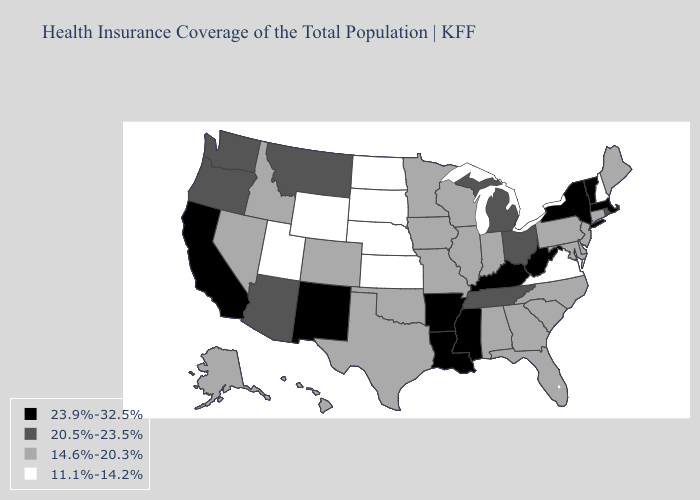What is the value of Utah?
Short answer required. 11.1%-14.2%. What is the highest value in states that border Tennessee?
Write a very short answer. 23.9%-32.5%. Does Alaska have the lowest value in the USA?
Write a very short answer. No. How many symbols are there in the legend?
Short answer required. 4. Which states have the highest value in the USA?
Short answer required. Arkansas, California, Kentucky, Louisiana, Massachusetts, Mississippi, New Mexico, New York, Vermont, West Virginia. Among the states that border Ohio , does Pennsylvania have the highest value?
Short answer required. No. Name the states that have a value in the range 11.1%-14.2%?
Be succinct. Kansas, Nebraska, New Hampshire, North Dakota, South Dakota, Utah, Virginia, Wyoming. Which states have the lowest value in the MidWest?
Be succinct. Kansas, Nebraska, North Dakota, South Dakota. Name the states that have a value in the range 14.6%-20.3%?
Quick response, please. Alabama, Alaska, Colorado, Connecticut, Delaware, Florida, Georgia, Hawaii, Idaho, Illinois, Indiana, Iowa, Maine, Maryland, Minnesota, Missouri, Nevada, New Jersey, North Carolina, Oklahoma, Pennsylvania, South Carolina, Texas, Wisconsin. Does Illinois have the highest value in the USA?
Quick response, please. No. Name the states that have a value in the range 23.9%-32.5%?
Quick response, please. Arkansas, California, Kentucky, Louisiana, Massachusetts, Mississippi, New Mexico, New York, Vermont, West Virginia. Which states have the highest value in the USA?
Keep it brief. Arkansas, California, Kentucky, Louisiana, Massachusetts, Mississippi, New Mexico, New York, Vermont, West Virginia. Does the map have missing data?
Answer briefly. No. Does Kentucky have the highest value in the USA?
Give a very brief answer. Yes. Which states have the lowest value in the West?
Keep it brief. Utah, Wyoming. 